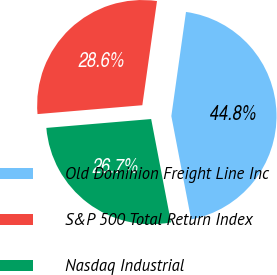<chart> <loc_0><loc_0><loc_500><loc_500><pie_chart><fcel>Old Dominion Freight Line Inc<fcel>S&P 500 Total Return Index<fcel>Nasdaq Industrial<nl><fcel>44.76%<fcel>28.57%<fcel>26.67%<nl></chart> 